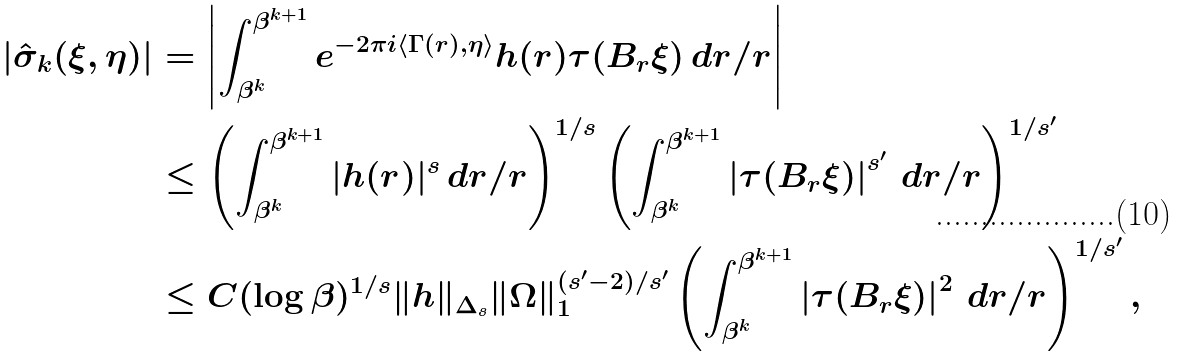Convert formula to latex. <formula><loc_0><loc_0><loc_500><loc_500>| \hat { \sigma } _ { k } ( \xi , \eta ) | & = \left | \int _ { \beta ^ { k } } ^ { \beta ^ { k + 1 } } e ^ { - 2 \pi i \langle \Gamma ( r ) , \eta \rangle } h ( r ) \tau ( B _ { r } \xi ) \, d r / r \right | \\ & \leq \left ( \int _ { \beta ^ { k } } ^ { \beta ^ { k + 1 } } | h ( r ) | ^ { s } \, d r / r \right ) ^ { 1 / s } \left ( \int _ { \beta ^ { k } } ^ { \beta ^ { k + 1 } } \left | \tau ( B _ { r } \xi ) \right | ^ { s ^ { \prime } } \, d r / r \right ) ^ { 1 / s ^ { \prime } } \\ & \leq C ( \log \beta ) ^ { 1 / s } \| h \| _ { \Delta _ { s } } \| \Omega \| _ { 1 } ^ { ( s ^ { \prime } - 2 ) / s ^ { \prime } } \left ( \int _ { \beta ^ { k } } ^ { \beta ^ { k + 1 } } \left | \tau ( B _ { r } \xi ) \right | ^ { 2 } \, d r / r \right ) ^ { 1 / s ^ { \prime } } ,</formula> 